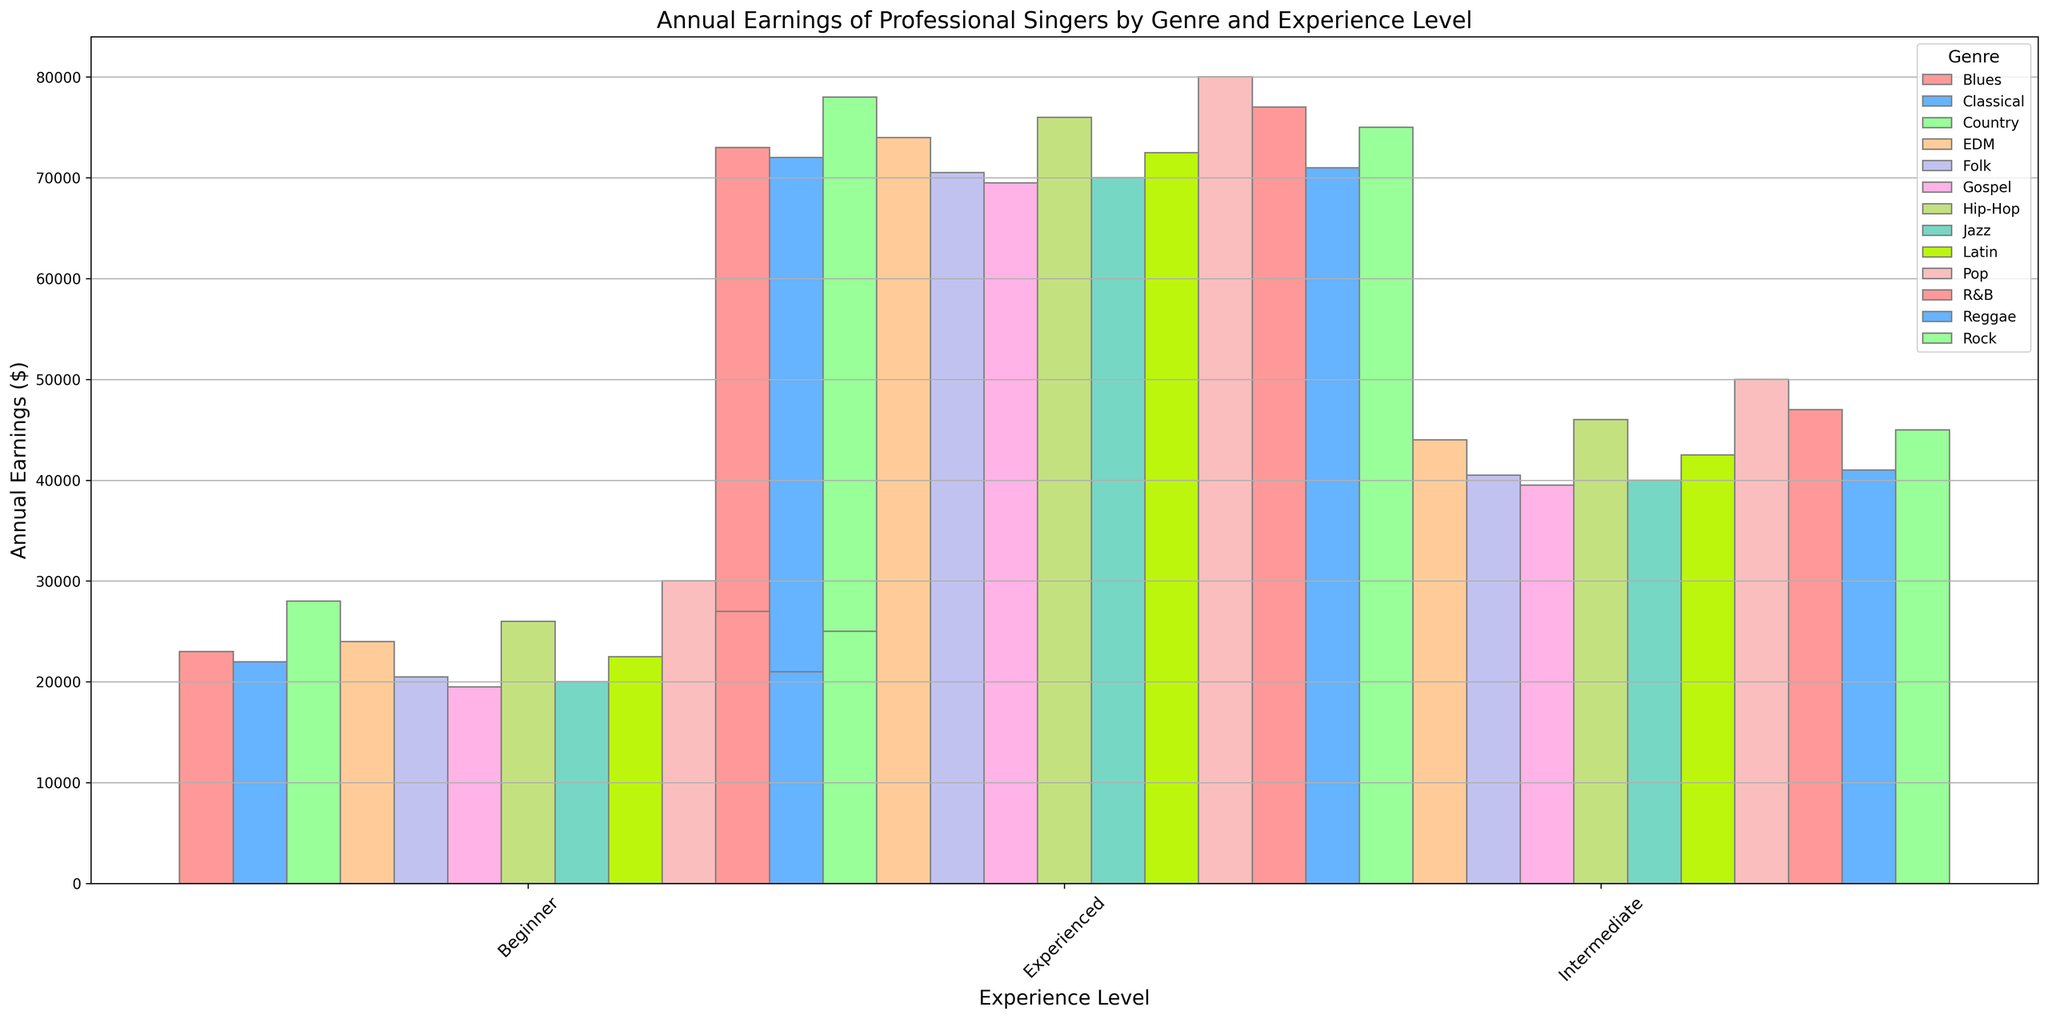Which genre has the highest annual earnings for experienced singers? Look at the bars representing experienced singers and identify the tallest. The tallest bar is for Pop, which means Pop has the highest annual earnings for experienced singers.
Answer: Pop Which genre has the lowest annual earnings for beginner singers? Look at the bars representing beginner singers and identify the shortest. The shortest bar is for Gospel, which means Gospel has the lowest annual earnings for beginner singers.
Answer: Gospel How much more do intermediate Pop singers earn compared to beginner Jazz singers? Find the height of the bar for intermediate Pop singers (50,000) and beginner Jazz singers (20,000). Compute the difference: 50,000 - 20,000 = 30,000.
Answer: 30,000 Which two genres have similar annual earnings for intermediate singers? Compare the bar heights for intermediate singers across all genres. Hip-Hop (46,000) and Rock (45,000) have similar earnings.
Answer: Hip-Hop and Rock What is the average annual earnings for experienced singers across all genres? Add up the annual earnings for experienced singers across all genres and divide by the number of genres. The sum is 80,000 + 75,000 + 70,000 + 72,000 + 78,000 + 76,000 + 74,000 + 73,000 + 77,000 + 71,000 + 72,500 + 69,500 + 70,500 = 909,500. There are 13 genres, so the average is 909,500 / 13 ≈ 69,000.
Answer: 69,000 Is there a genre where intermediate singers earn more than experienced singers? Compare the bar heights of intermediate and experienced singers for each genre. No intermediate bar is higher than the experienced counterpart.
Answer: No Which experience level has the highest earnings across all genres? Compare the highest bars across beginner, intermediate, and experienced levels. The highest earnings is experienced Pop singers at 80,000, indicating experienced level has the highest earnings across all genres.
Answer: Experienced Do beginner singers in any genre earn more than intermediate singers in another genre? Compare the maximum earnings for beginner singers (Pop, 30,000) with the minimum for intermediate singers (Jazz, 40,000). No beginner earnings exceed intermediate earnings.
Answer: No What is the total earnings difference between beginner and experienced singers in the EDM genre? Find the earnings for beginner EDM singers (24,000) and experienced EDM singers (74,000). Compute the difference: 74,000 - 24,000 = 50,000.
Answer: 50,000 For which genre do experienced singers earn exactly 70,000? Look for the bar representing experienced singers that reaches the 70,000 mark. Jazz matches this description.
Answer: Jazz 